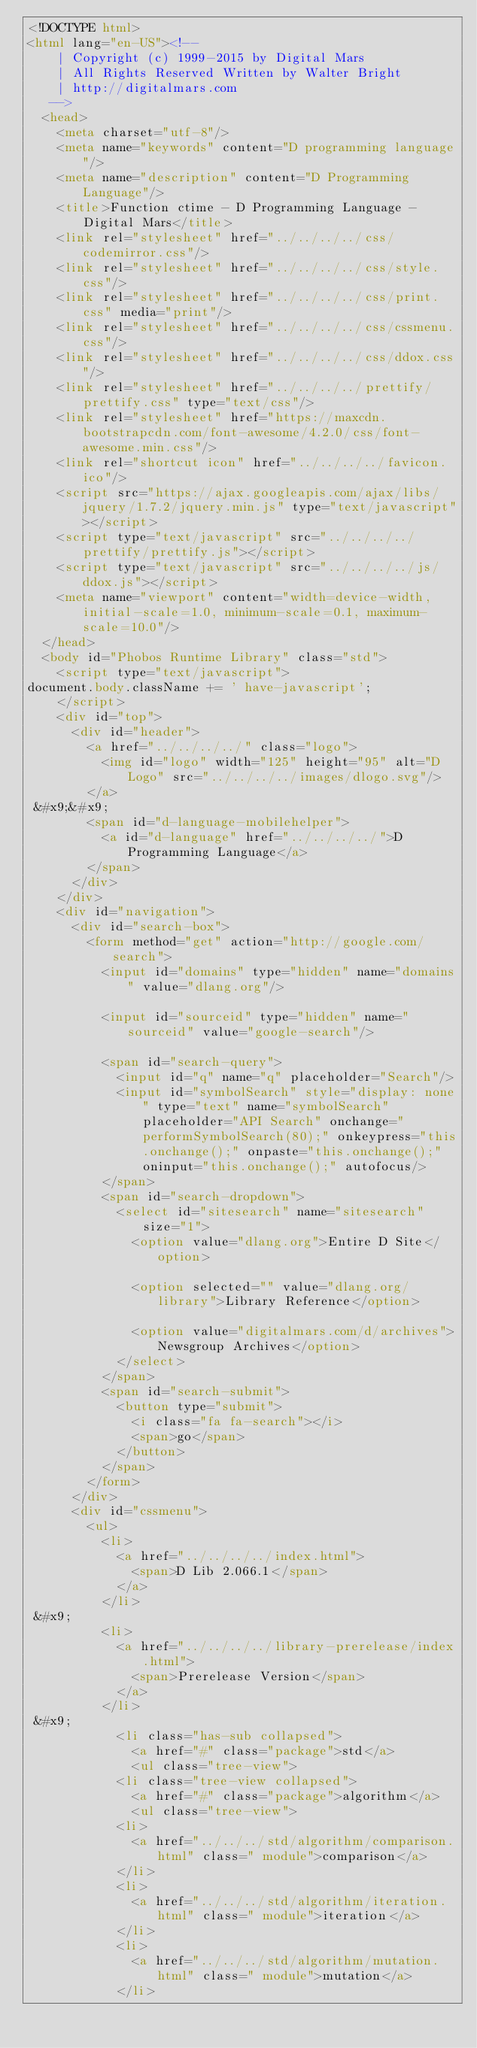Convert code to text. <code><loc_0><loc_0><loc_500><loc_500><_HTML_><!DOCTYPE html>
<html lang="en-US"><!-- 
    | Copyright (c) 1999-2015 by Digital Mars
    | All Rights Reserved Written by Walter Bright
    | http://digitalmars.com
	 -->
	<head>
		<meta charset="utf-8"/>
		<meta name="keywords" content="D programming language"/>
		<meta name="description" content="D Programming Language"/>
		<title>Function ctime - D Programming Language - Digital Mars</title>
		<link rel="stylesheet" href="../../../../css/codemirror.css"/>
		<link rel="stylesheet" href="../../../../css/style.css"/>
		<link rel="stylesheet" href="../../../../css/print.css" media="print"/>
		<link rel="stylesheet" href="../../../../css/cssmenu.css"/>
		<link rel="stylesheet" href="../../../../css/ddox.css"/>
		<link rel="stylesheet" href="../../../../prettify/prettify.css" type="text/css"/>
		<link rel="stylesheet" href="https://maxcdn.bootstrapcdn.com/font-awesome/4.2.0/css/font-awesome.min.css"/>
		<link rel="shortcut icon" href="../../../../favicon.ico"/>
		<script src="https://ajax.googleapis.com/ajax/libs/jquery/1.7.2/jquery.min.js" type="text/javascript"></script>
		<script type="text/javascript" src="../../../../prettify/prettify.js"></script>
		<script type="text/javascript" src="../../../../js/ddox.js"></script>
		<meta name="viewport" content="width=device-width, initial-scale=1.0, minimum-scale=0.1, maximum-scale=10.0"/>
	</head>
	<body id="Phobos Runtime Library" class="std">
		<script type="text/javascript">
document.body.className += ' have-javascript';
		</script>
		<div id="top">
			<div id="header">
				<a href="../../../../" class="logo">
					<img id="logo" width="125" height="95" alt="D Logo" src="../../../../images/dlogo.svg"/>
				</a>
 &#x9;&#x9;
				<span id="d-language-mobilehelper">
					<a id="d-language" href="../../../../">D Programming Language</a>
				</span>
			</div>
		</div>
		<div id="navigation">
			<div id="search-box">
				<form method="get" action="http://google.com/search">
					<input id="domains" type="hidden" name="domains" value="dlang.org"/>
             
					<input id="sourceid" type="hidden" name="sourceid" value="google-search"/>
             
					<span id="search-query">
						<input id="q" name="q" placeholder="Search"/>
						<input id="symbolSearch" style="display: none" type="text" name="symbolSearch" placeholder="API Search" onchange="performSymbolSearch(80);" onkeypress="this.onchange();" onpaste="this.onchange();" oninput="this.onchange();" autofocus/>
					</span>
					<span id="search-dropdown">
						<select id="sitesearch" name="sitesearch" size="1">
							<option value="dlang.org">Entire D Site</option>
                     
							<option selected="" value="dlang.org/library">Library Reference</option>
                     
							<option value="digitalmars.com/d/archives">Newsgroup Archives</option>
						</select>
					</span>
					<span id="search-submit">
						<button type="submit">
							<i class="fa fa-search"></i>
							<span>go</span>
						</button>
					</span>
				</form>
			</div>
			<div id="cssmenu">
				<ul>
					<li>
						<a href="../../../../index.html">
							<span>D Lib 2.066.1</span>
						</a>
					</li>
 &#x9;
					<li>
						<a href="../../../../library-prerelease/index.html">
							<span>Prerelease Version</span>
						</a>
					</li>
 &#x9;
						<li class="has-sub collapsed">
							<a href="#" class="package">std</a>
							<ul class="tree-view">
						<li class="tree-view collapsed">
							<a href="#" class="package">algorithm</a>
							<ul class="tree-view">
						<li>
							<a href="../../../std/algorithm/comparison.html" class=" module">comparison</a>
						</li>
						<li>
							<a href="../../../std/algorithm/iteration.html" class=" module">iteration</a>
						</li>
						<li>
							<a href="../../../std/algorithm/mutation.html" class=" module">mutation</a>
						</li></code> 